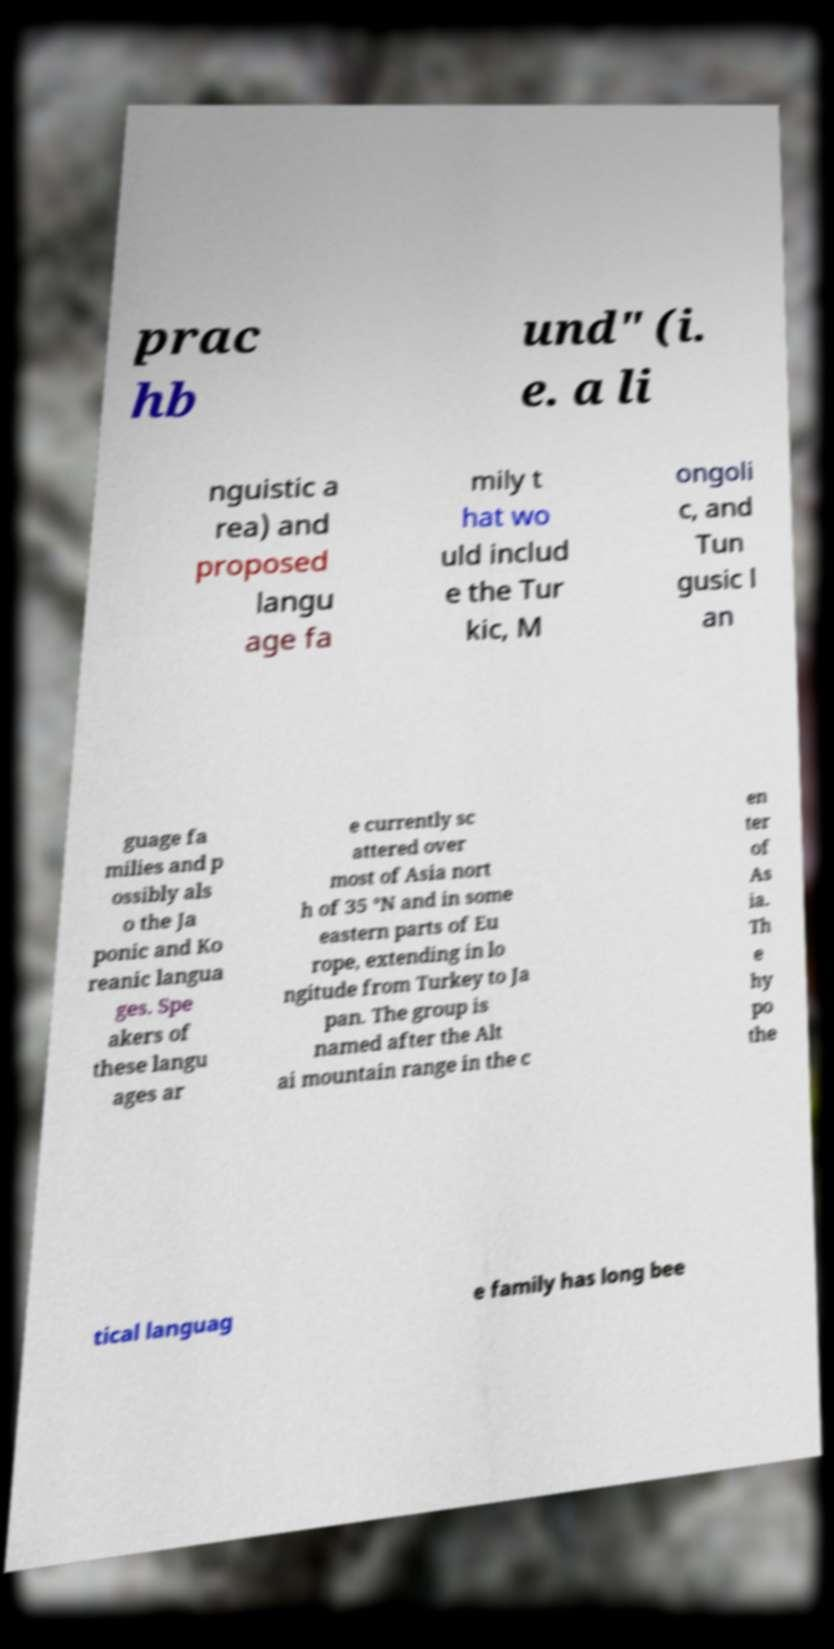Please identify and transcribe the text found in this image. prac hb und" (i. e. a li nguistic a rea) and proposed langu age fa mily t hat wo uld includ e the Tur kic, M ongoli c, and Tun gusic l an guage fa milies and p ossibly als o the Ja ponic and Ko reanic langua ges. Spe akers of these langu ages ar e currently sc attered over most of Asia nort h of 35 °N and in some eastern parts of Eu rope, extending in lo ngitude from Turkey to Ja pan. The group is named after the Alt ai mountain range in the c en ter of As ia. Th e hy po the tical languag e family has long bee 